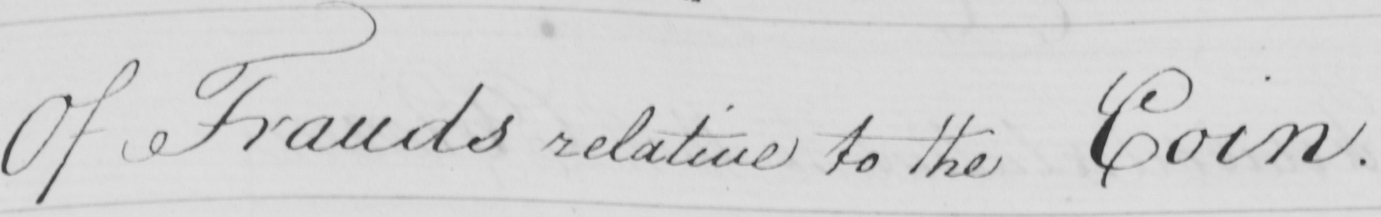Please transcribe the handwritten text in this image. Of Frauds relative to the Coin . 